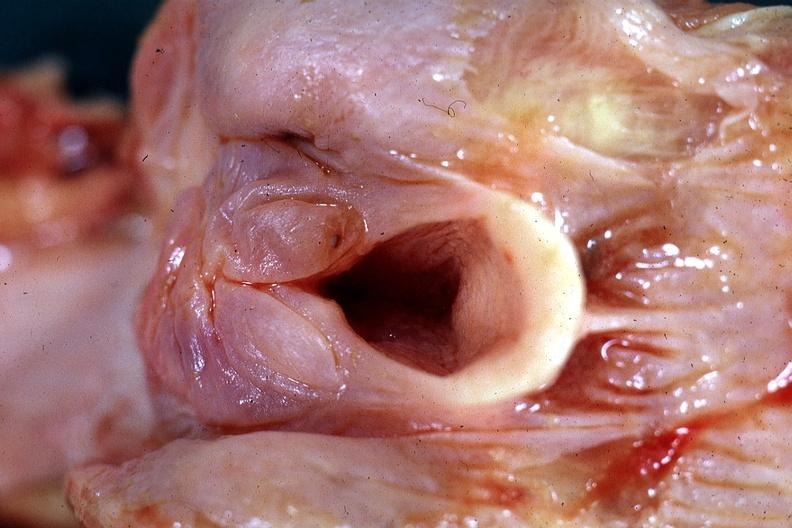s edema hypopharynx present?
Answer the question using a single word or phrase. Yes 